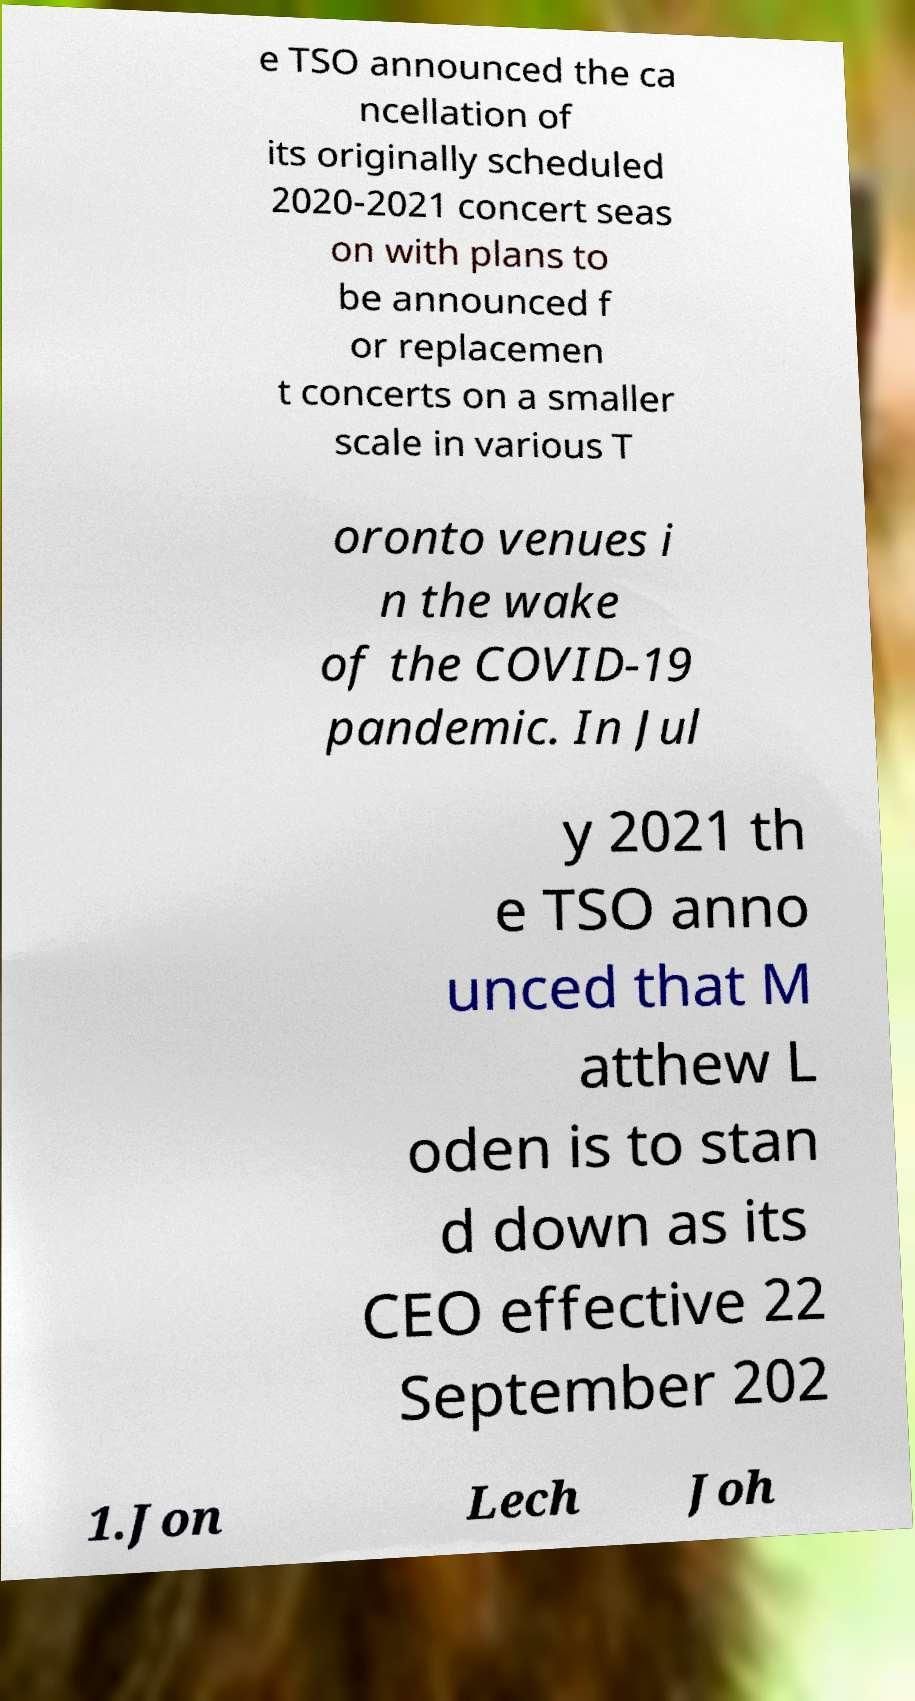Could you assist in decoding the text presented in this image and type it out clearly? e TSO announced the ca ncellation of its originally scheduled 2020-2021 concert seas on with plans to be announced f or replacemen t concerts on a smaller scale in various T oronto venues i n the wake of the COVID-19 pandemic. In Jul y 2021 th e TSO anno unced that M atthew L oden is to stan d down as its CEO effective 22 September 202 1.Jon Lech Joh 